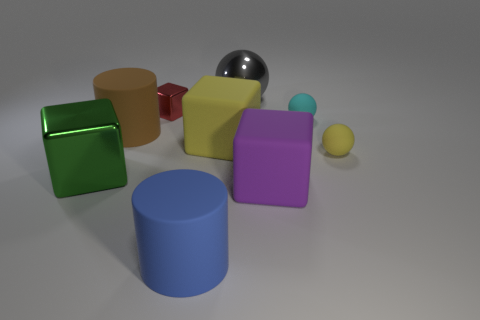The small object to the left of the large matte object that is to the right of the big gray object is what shape?
Your response must be concise. Cube. There is a yellow object on the right side of the large yellow rubber cube; is its shape the same as the large gray metal object?
Offer a very short reply. Yes. There is a rubber thing that is in front of the purple object; what color is it?
Make the answer very short. Blue. How many blocks are red metal things or big green metal things?
Ensure brevity in your answer.  2. What size is the rubber cube that is right of the big thing behind the small red metal object?
Ensure brevity in your answer.  Large. There is a big yellow matte thing; how many rubber cubes are right of it?
Give a very brief answer. 1. Are there fewer small cubes than blue matte balls?
Keep it short and to the point. No. How big is the thing that is on the right side of the purple object and left of the yellow matte sphere?
Ensure brevity in your answer.  Small. Is the number of brown rubber cylinders that are on the right side of the tiny cyan ball less than the number of small cyan matte objects?
Ensure brevity in your answer.  Yes. What shape is the large gray object that is made of the same material as the tiny red cube?
Provide a short and direct response. Sphere. 